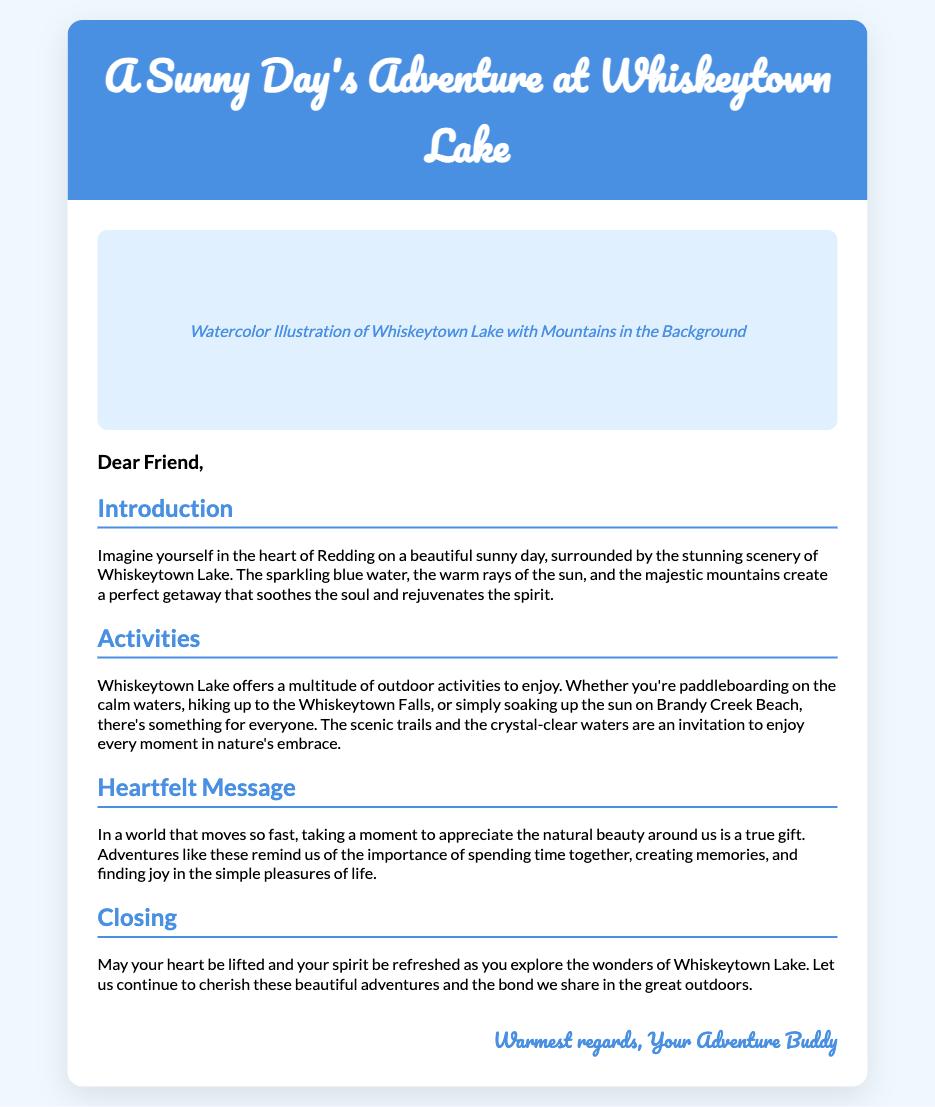what is the title of the card? The title of the card is located in the header section, which states the purpose of the card and its content.
Answer: A Sunny Day's Adventure at Whiskeytown Lake what is illustrated in the placeholder? The image placeholder informs about the visual content that represents the subject of the card.
Answer: Watercolor Illustration of Whiskeytown Lake with Mountains in the Background how many activities are mentioned in the document? The document discusses various activities offered at Whiskeytown Lake, indicating how many different options are highlighted.
Answer: Multiple (implying more than two) what is the first activity mentioned? The first activity in the document's activities section specifies the initial option to be enjoyed at Whiskeytown Lake.
Answer: Paddleboarding who is the greeting card addressed to? The greeting card starts with a salutation that indicates to whom the card is directed.
Answer: Friend what is the tone of the heartfelt message? The overall feeling conveyed in the heartfelt message indicates the emotion embraced throughout the document.
Answer: Heartfelt what geographical location is highlighted in the card? The geographical focus of the card is specified in the title and introduction, which establishes the setting for the adventure.
Answer: Whiskeytown Lake what is the significance of nature mentioned in the card? The document emphasizes the importance of nature in creating special memories and moments, highlighting its emotional value.
Answer: A true gift 